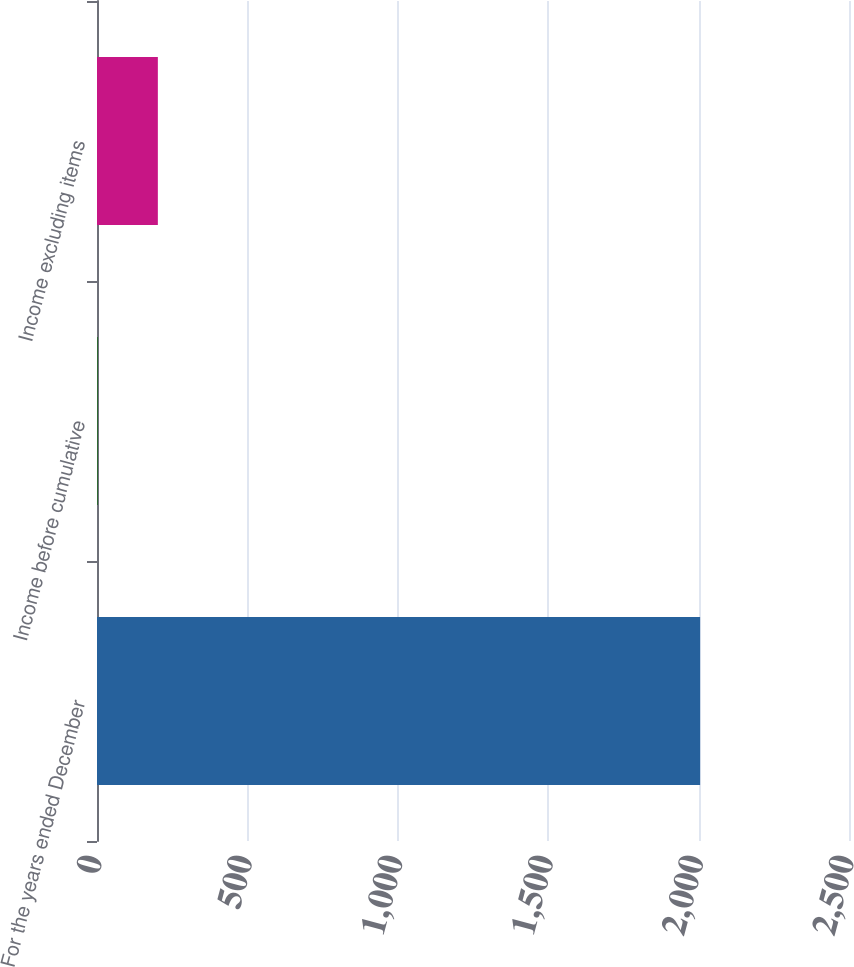<chart> <loc_0><loc_0><loc_500><loc_500><bar_chart><fcel>For the years ended December<fcel>Income before cumulative<fcel>Income excluding items<nl><fcel>2005<fcel>1.99<fcel>202.29<nl></chart> 